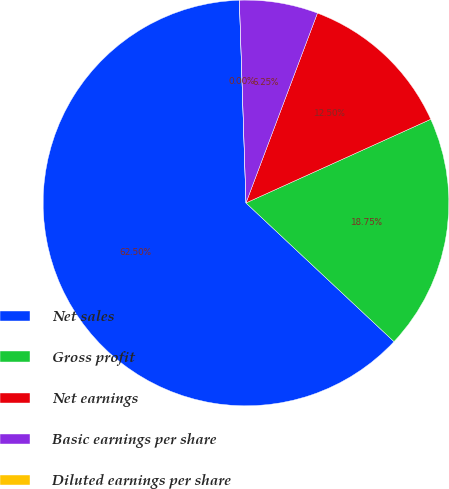Convert chart to OTSL. <chart><loc_0><loc_0><loc_500><loc_500><pie_chart><fcel>Net sales<fcel>Gross profit<fcel>Net earnings<fcel>Basic earnings per share<fcel>Diluted earnings per share<nl><fcel>62.5%<fcel>18.75%<fcel>12.5%<fcel>6.25%<fcel>0.0%<nl></chart> 